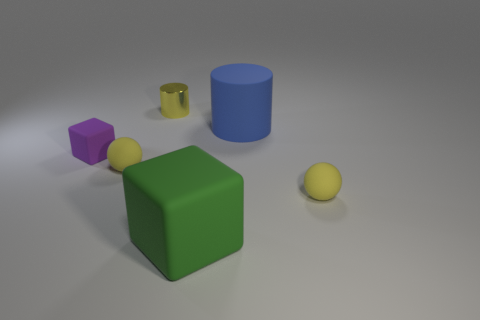What number of small purple blocks have the same material as the green block?
Make the answer very short. 1. Is the material of the big object that is behind the green cube the same as the block that is to the left of the large green object?
Make the answer very short. Yes. There is a blue cylinder that is behind the yellow sphere that is on the left side of the large block; what number of small rubber cubes are on the right side of it?
Offer a very short reply. 0. There is a rubber block that is left of the tiny yellow metallic cylinder; does it have the same color as the tiny sphere to the left of the big blue rubber cylinder?
Make the answer very short. No. Are there any other things that have the same color as the small shiny cylinder?
Offer a very short reply. Yes. What is the color of the matte block that is in front of the small rubber ball to the right of the yellow metallic cylinder?
Make the answer very short. Green. Are there any yellow metallic things?
Offer a very short reply. Yes. There is a object that is both left of the small cylinder and right of the tiny block; what color is it?
Offer a terse response. Yellow. Is the size of the block that is to the left of the big block the same as the sphere that is to the left of the yellow metal thing?
Offer a very short reply. Yes. What number of other things are the same size as the blue rubber object?
Ensure brevity in your answer.  1. 